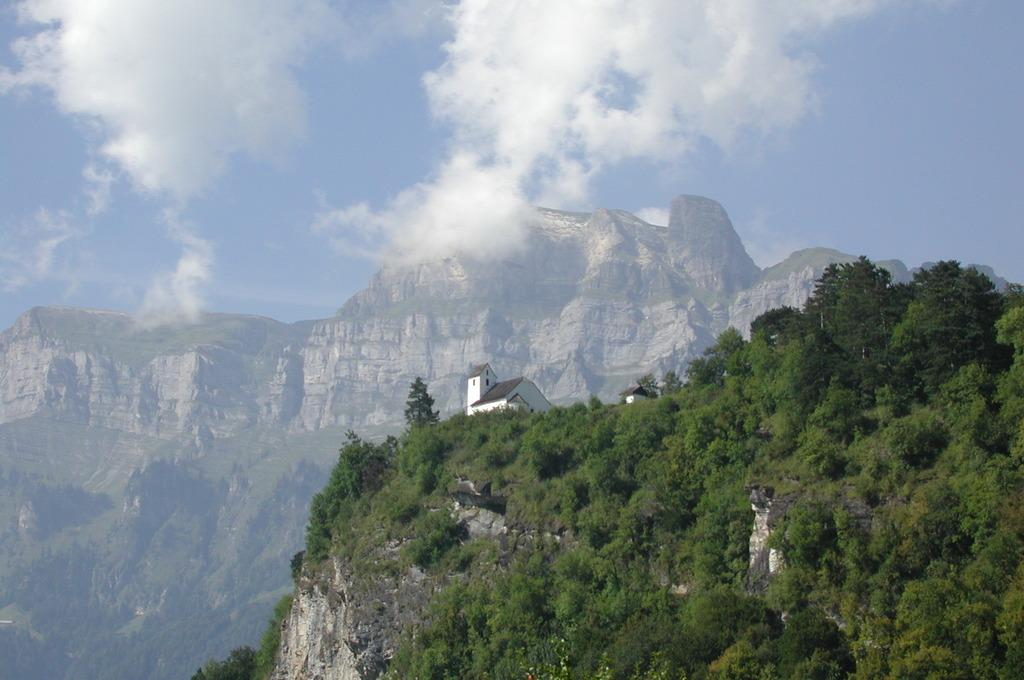What type of structure is shown in the image? The image appears to depict a house. What can be seen in the foreground of the image? There are trees and plants visible in the image. What is visible in the distance in the image? There are mountains in the background of the image. What is the condition of the sky in the image? Clouds are present in the sky. What type of shirt is the body wearing in the image? There is no body or shirt present in the image; it depicts a house, trees, plants, mountains, and clouds. 